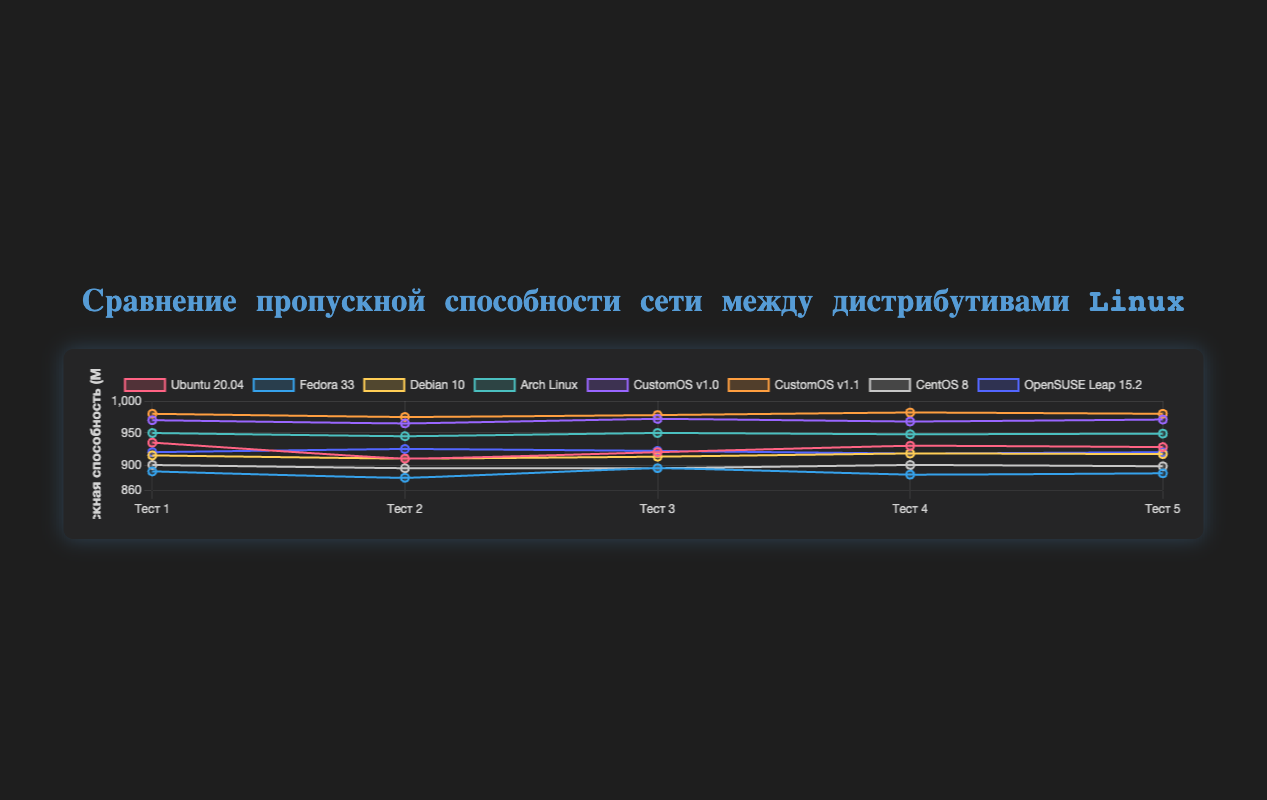Which distribution shows the highest network throughput in any test? By observing the figure, the distribution "CustomOS v1.1" has the highest throughput in multiple tests with a value of 982 Mbps in test 4.
Answer: CustomOS v1.1 Which two distributions have consistently high throughput across all tests? By identifying the distributions with consistently high values across all tests, it’s clear that "Arch Linux" and "CustomOS v1.1" maintain the highest values in throughput consistently.
Answer: Arch Linux and CustomOS v1.1 How does the throughput of Ubuntu 20.04 compare to Fedora 33 in test 3? Observing test 3, Ubuntu 20.04 has a throughput of 920 Mbps and Fedora 33 has a throughput of 895 Mbps. Thus, Ubuntu 20.04 has a higher throughput.
Answer: Ubuntu 20.04 has a higher throughput Which distribution has the lowest average throughput across all tests? Calculate the average for each distribution by summing their values and dividing by the number of tests. Fedora 33 consistently shows lower values, giving it the lowest average.
Answer: Fedora 33 Which custom OS version has shown improvement in throughput from version 1.0 to 1.1? By comparing CustomOS v1.0 and CustomOS v1.1, v1.1 has higher throughput values across all tests indicating an improvement.
Answer: CustomOS What is the average throughput of CentOS 8 and Debian 10 combined across all tests? To find the average, sum the throughput values for both distributions and divide by the number of tests times the number of distributions. (900+895+895+900+898) + (915+910+913+918+917) = 9181 / 10 = 918.1 Mbps
Answer: 918.1 Mbps Which distribution shows the most variability in the throughput values across the tests? By comparing the ranges (max - min) of the throughput values for each distribution, "Fedora 33" shows the most variability with a range of 895 - 880 = 15.
Answer: Fedora 33 What is the total throughput of all distributions for test 2? Sum the throughput values of each distribution for test 2. 910 + 880 + 910 + 945 + 965 + 975 + 895 + 925 = 6405 Mbps
Answer: 6405 Mbps Which distribution has the highest minimum throughput in any test? By comparing the minimum values of throughput for each distribution, "CustomOS v1.1" has the highest minimum throughput at 975 Mbps.
Answer: CustomOS v1.1 